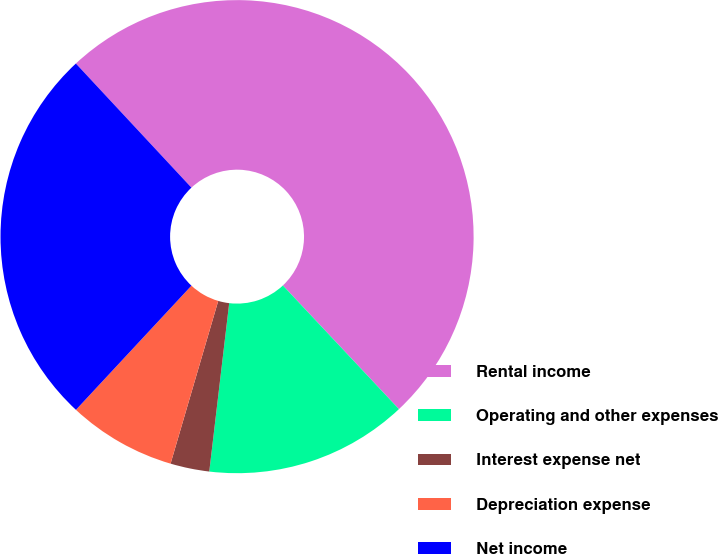Convert chart to OTSL. <chart><loc_0><loc_0><loc_500><loc_500><pie_chart><fcel>Rental income<fcel>Operating and other expenses<fcel>Interest expense net<fcel>Depreciation expense<fcel>Net income<nl><fcel>49.93%<fcel>13.87%<fcel>2.66%<fcel>7.39%<fcel>26.14%<nl></chart> 